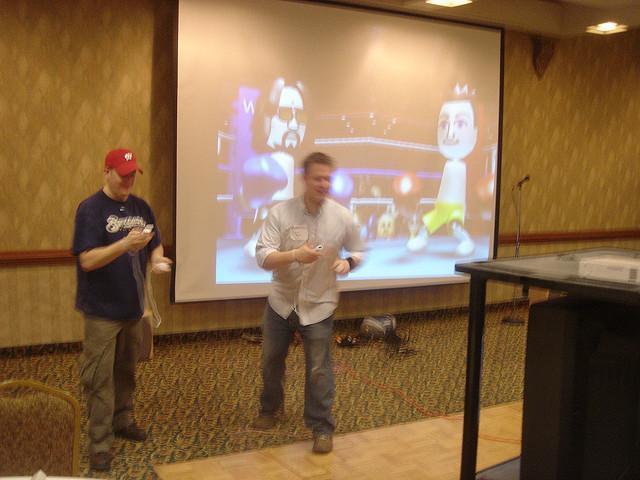How many tvs are visible?
Give a very brief answer. 2. How many people are in the photo?
Give a very brief answer. 2. 